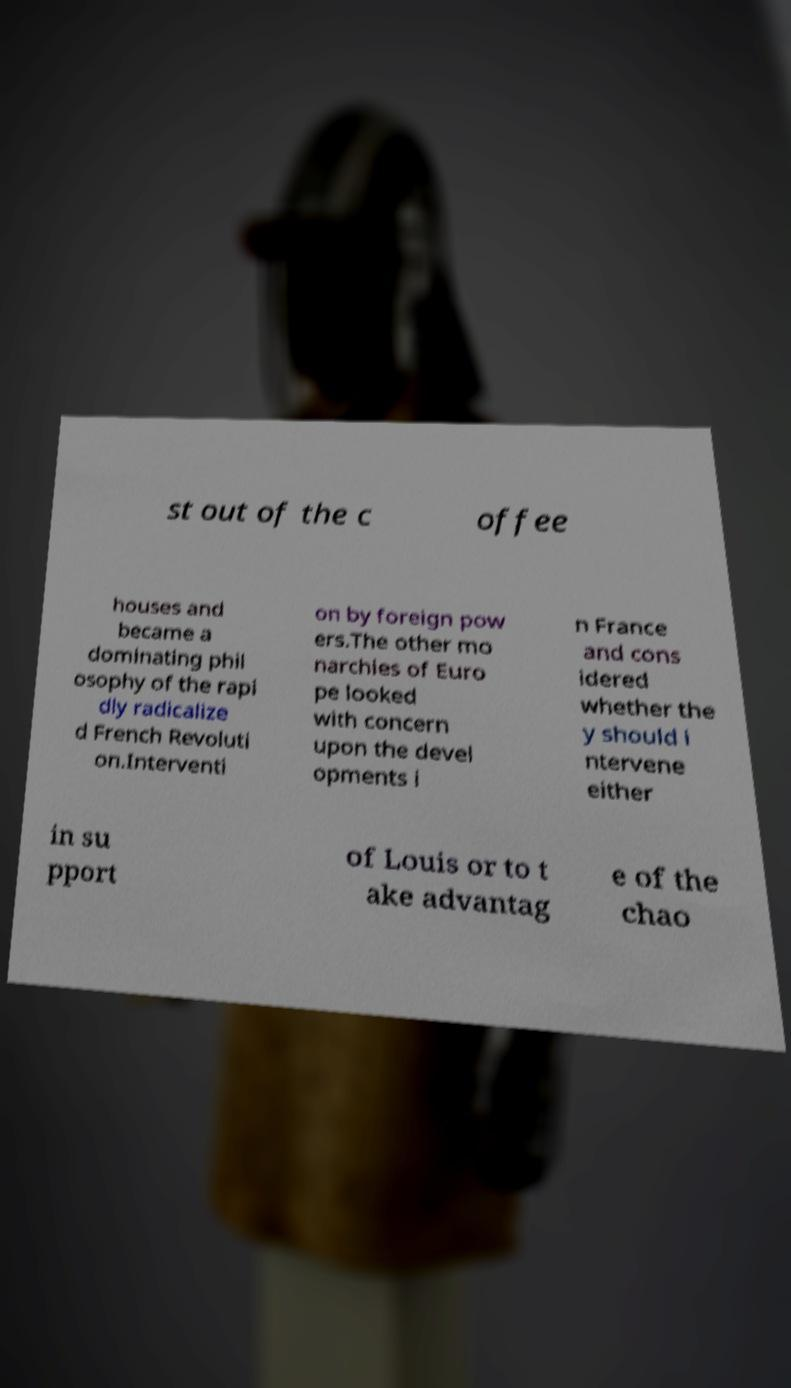For documentation purposes, I need the text within this image transcribed. Could you provide that? st out of the c offee houses and became a dominating phil osophy of the rapi dly radicalize d French Revoluti on.Interventi on by foreign pow ers.The other mo narchies of Euro pe looked with concern upon the devel opments i n France and cons idered whether the y should i ntervene either in su pport of Louis or to t ake advantag e of the chao 